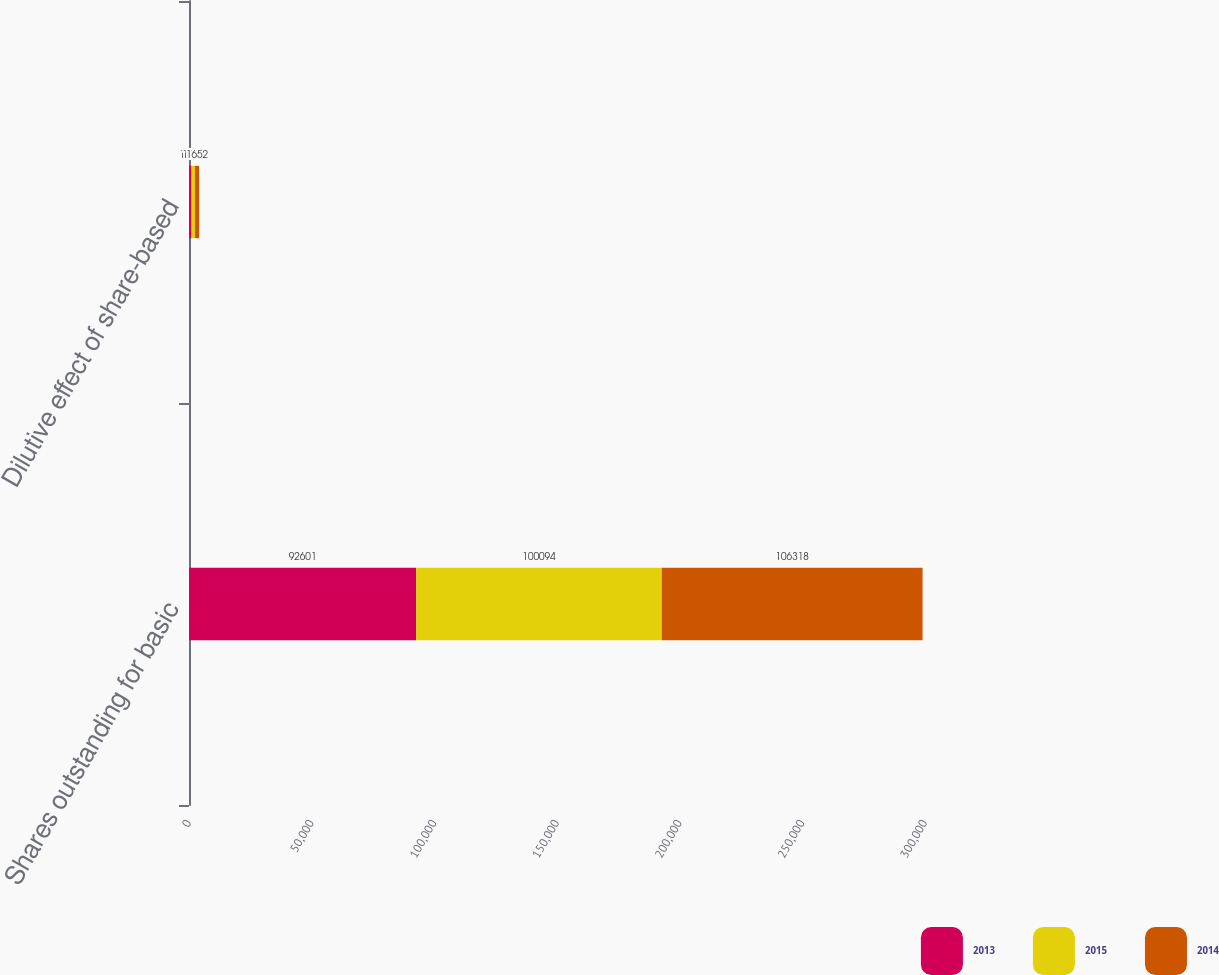Convert chart. <chart><loc_0><loc_0><loc_500><loc_500><stacked_bar_chart><ecel><fcel>Shares outstanding for basic<fcel>Dilutive effect of share-based<nl><fcel>2013<fcel>92601<fcel>1048<nl><fcel>2015<fcel>100094<fcel>1409<nl><fcel>2014<fcel>106318<fcel>1652<nl></chart> 